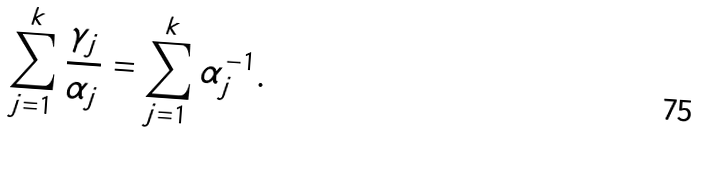<formula> <loc_0><loc_0><loc_500><loc_500>\sum ^ { k } _ { j = 1 } \frac { \gamma _ { j } } { \alpha _ { j } } = \sum ^ { k } _ { j = 1 } \alpha ^ { - 1 } _ { j } .</formula> 